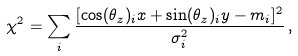Convert formula to latex. <formula><loc_0><loc_0><loc_500><loc_500>\chi ^ { 2 } = \sum _ { i } \frac { [ \cos ( \theta _ { z } ) _ { i } x + \sin ( \theta _ { z } ) _ { i } y - m _ { i } ] ^ { 2 } } { \sigma _ { i } ^ { 2 } } \, ,</formula> 